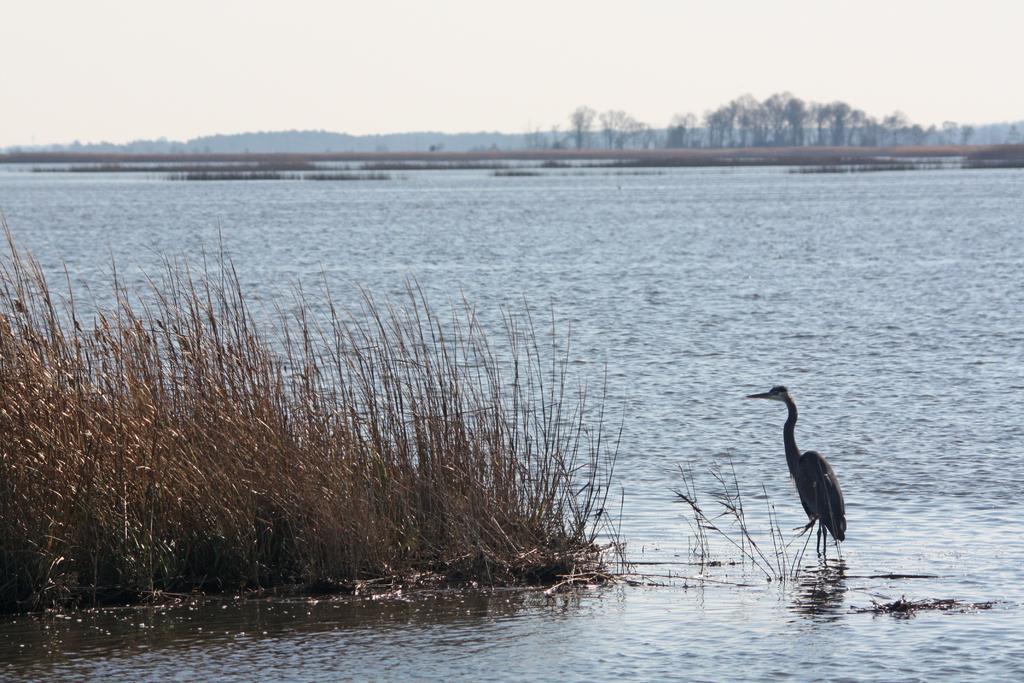Describe this image in one or two sentences. In this image we can see a bird in the water, there are some plants, trees and mountains, in the background we can see the sky. 